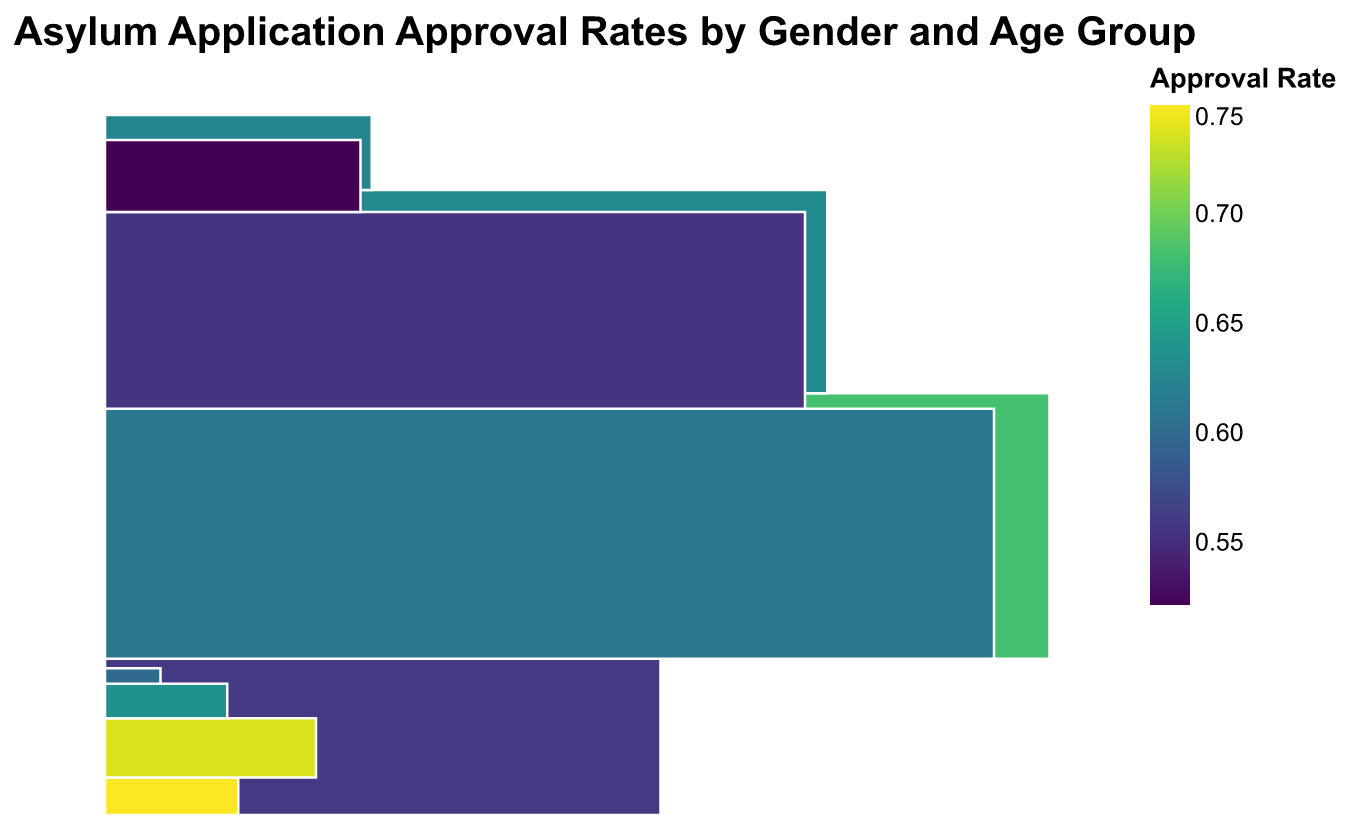What does the color represent in the mosaic plot? The color represents the approval rate of asylum applications, with different shades indicating different approval rates.
Answer: Approval rate Which gender and age group has the highest approval rate? From the color scale, the darkest shade (representing the highest approval rate) appears in the LGBTQ+ age group of 18-25.
Answer: LGBTQ+ 18-25 How does the approval rate for males aged 26-40 compare to that of females in the same age group? By comparing the color shade of males and females in the 26-40 age group, females have a lighter shade, indicating a higher approval rate for males in the 26-40 age group.
Answer: Males aged 26-40 have a higher approval rate What is the total number of asylum applications for females aged 41-60? The total number of applications can be derived by summing the approved and denied cases for females aged 41-60. By adding 410 (approved) + 240 (denied), we get 650.
Answer: 650 Which age group among females has the lowest approval rate? The lightest shaded block among the four female age groups indicates the lowest approval rate, which is the 60+ age group.
Answer: 60+ How does the approval rate of LGBTQ+ individuals aged 26-40 compare to that of males aged 26-40? By comparing the color shades, LGBTQ+ individuals aged 26-40 have a lighter shade than males of the same age group, indicating a lower approval rate for LGBTQ+ individuals.
Answer: Lower for LGBTQ+ individuals aged 26-40 In terms of application volume, which gender and age group submitted the most asylum applications? The biggest section in terms of width (indicating a larger number of total applications) belongs to females aged 26-40.
Answer: Females aged 26-40 What is the overall approval rate trend across different age groups for males? Observing the color shades, it's noticeable that the younger age groups generally have darker shades, indicating a higher approval rate, which decreases as the age groups get older.
Answer: Decreasing with age Between females aged 18-25 and LGBTQ+ individuals aged 18-25, which has a higher denial rate? Looking at the relative size of the denied sections, females aged 18-25 have a wider denied section compared to LGBTQ+ individuals of the same age group, indicating a higher denial rate for females.
Answer: Females aged 18-25 What insight can be drawn about the approval rates for the 60+ age group across different genders? The color shades for the 60+ age group across all genders (Female, Male, LGBTQ+) are relatively light, indicating that the approval rates are generally low for asylum applicants in the 60+ age group regardless of gender.
Answer: Low approval rates across all genders 